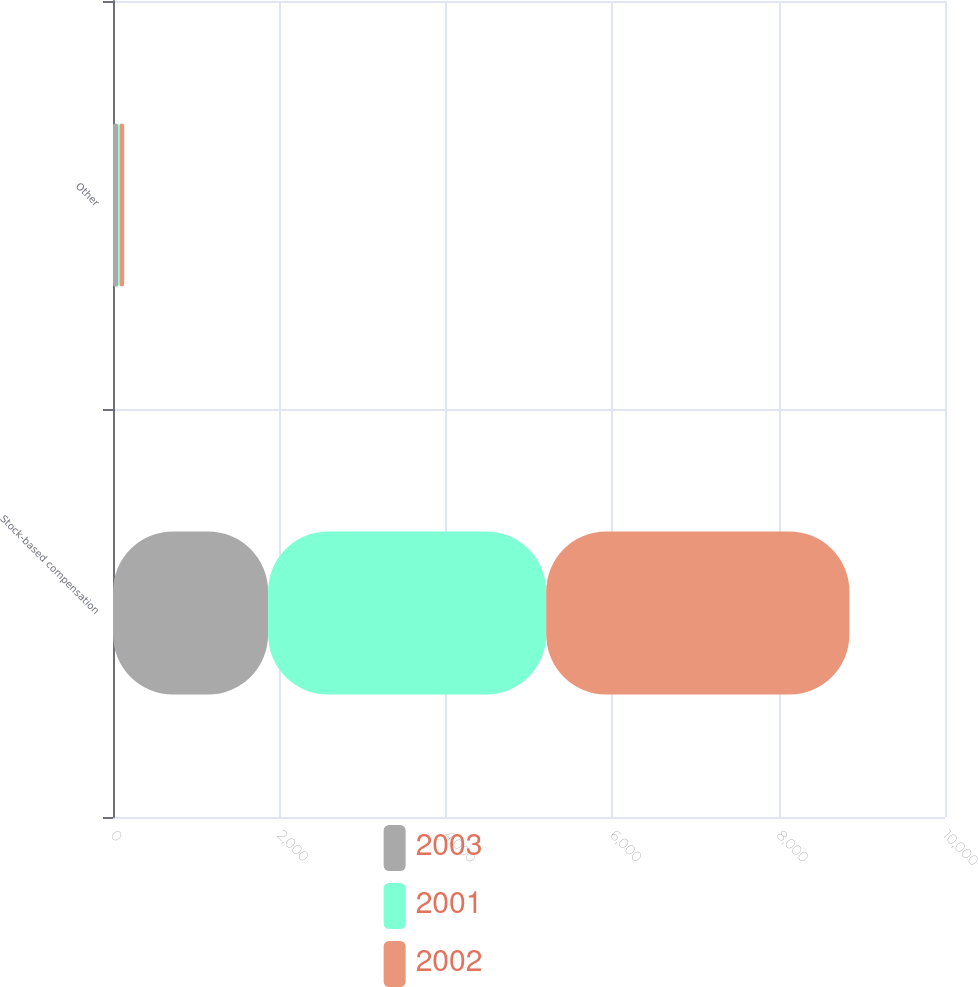<chart> <loc_0><loc_0><loc_500><loc_500><stacked_bar_chart><ecel><fcel>Stock-based compensation<fcel>Other<nl><fcel>2003<fcel>1864<fcel>64<nl><fcel>2001<fcel>3343<fcel>15<nl><fcel>2002<fcel>3644<fcel>56<nl></chart> 